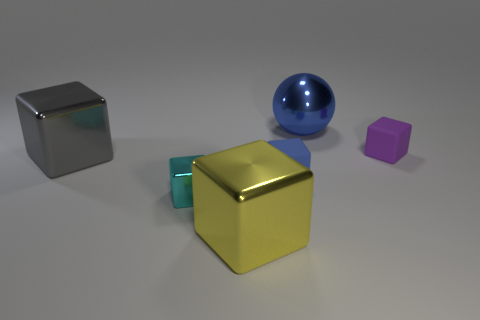Subtract all blue blocks. How many blocks are left? 4 Subtract 1 blocks. How many blocks are left? 4 Subtract all cyan blocks. How many blocks are left? 4 Subtract all red cubes. Subtract all brown cylinders. How many cubes are left? 5 Add 4 big gray things. How many objects exist? 10 Subtract all blocks. How many objects are left? 1 Add 2 small blue blocks. How many small blue blocks exist? 3 Subtract 0 purple spheres. How many objects are left? 6 Subtract all gray shiny cubes. Subtract all large brown metallic things. How many objects are left? 5 Add 2 big yellow metal things. How many big yellow metal things are left? 3 